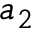<formula> <loc_0><loc_0><loc_500><loc_500>a _ { 2 }</formula> 